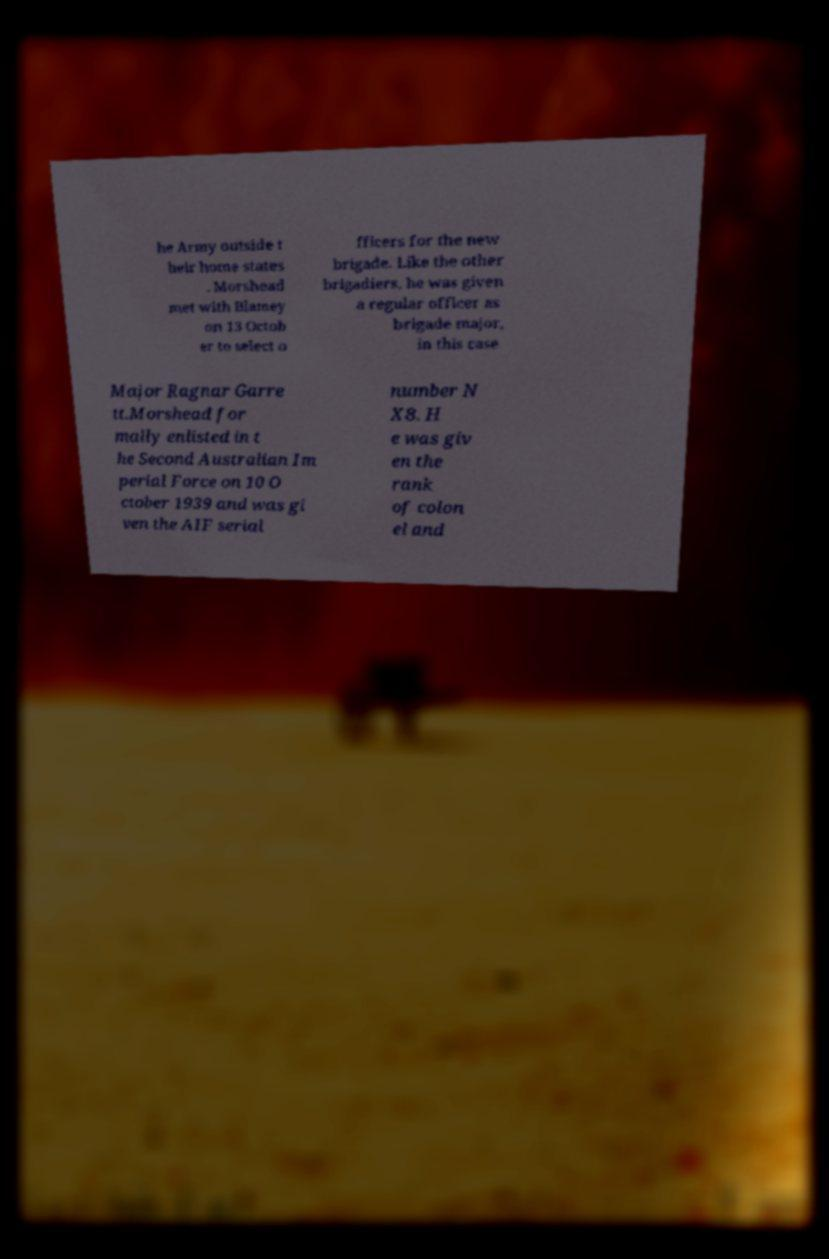For documentation purposes, I need the text within this image transcribed. Could you provide that? he Army outside t heir home states . Morshead met with Blamey on 13 Octob er to select o fficers for the new brigade. Like the other brigadiers, he was given a regular officer as brigade major, in this case Major Ragnar Garre tt.Morshead for mally enlisted in t he Second Australian Im perial Force on 10 O ctober 1939 and was gi ven the AIF serial number N X8. H e was giv en the rank of colon el and 